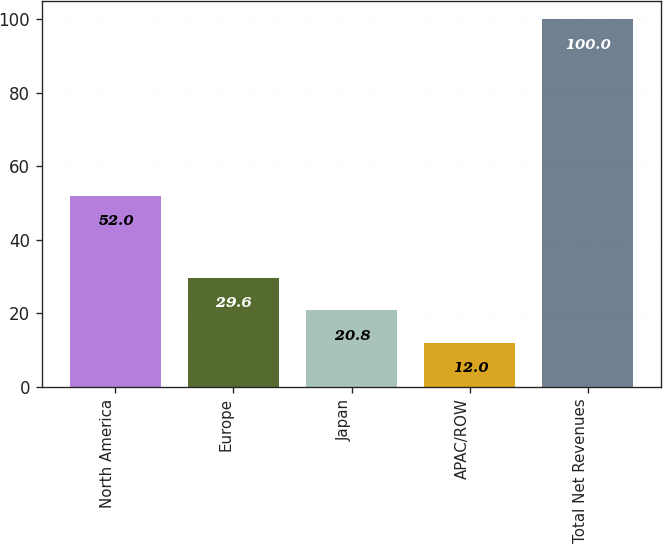<chart> <loc_0><loc_0><loc_500><loc_500><bar_chart><fcel>North America<fcel>Europe<fcel>Japan<fcel>APAC/ROW<fcel>Total Net Revenues<nl><fcel>52<fcel>29.6<fcel>20.8<fcel>12<fcel>100<nl></chart> 